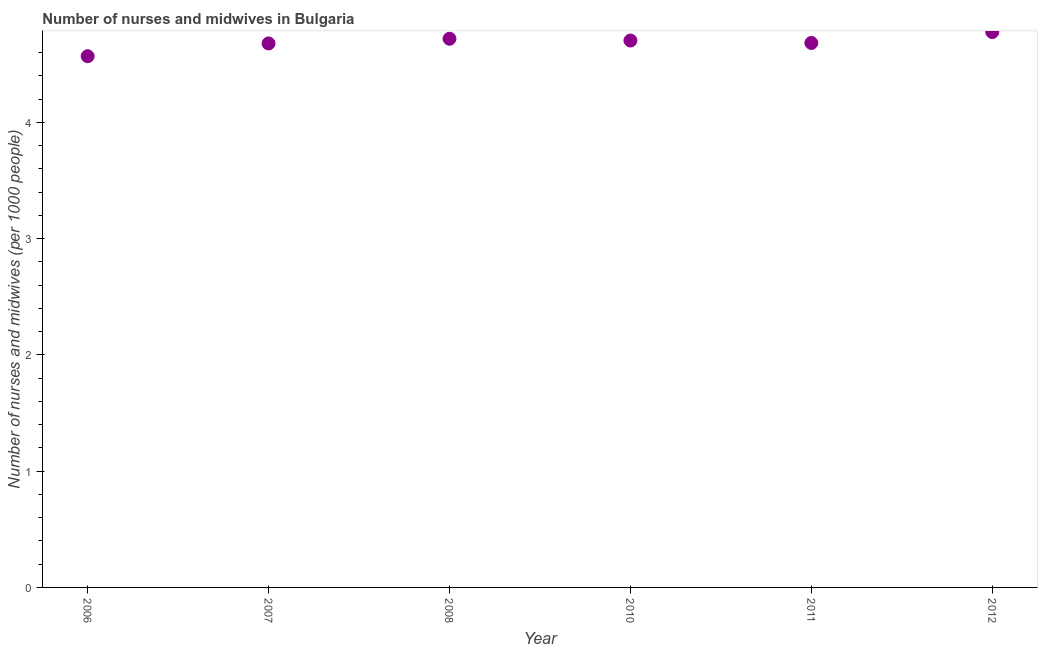What is the number of nurses and midwives in 2011?
Offer a terse response. 4.68. Across all years, what is the maximum number of nurses and midwives?
Offer a terse response. 4.78. Across all years, what is the minimum number of nurses and midwives?
Offer a terse response. 4.57. In which year was the number of nurses and midwives maximum?
Your response must be concise. 2012. In which year was the number of nurses and midwives minimum?
Offer a very short reply. 2006. What is the sum of the number of nurses and midwives?
Offer a very short reply. 28.14. What is the difference between the number of nurses and midwives in 2006 and 2011?
Your answer should be compact. -0.11. What is the average number of nurses and midwives per year?
Your answer should be very brief. 4.69. What is the median number of nurses and midwives?
Give a very brief answer. 4.69. In how many years, is the number of nurses and midwives greater than 2 ?
Offer a very short reply. 6. Do a majority of the years between 2012 and 2011 (inclusive) have number of nurses and midwives greater than 1.4 ?
Keep it short and to the point. No. What is the ratio of the number of nurses and midwives in 2006 to that in 2011?
Ensure brevity in your answer.  0.98. Is the difference between the number of nurses and midwives in 2007 and 2008 greater than the difference between any two years?
Your answer should be compact. No. What is the difference between the highest and the second highest number of nurses and midwives?
Offer a terse response. 0.06. Is the sum of the number of nurses and midwives in 2006 and 2007 greater than the maximum number of nurses and midwives across all years?
Ensure brevity in your answer.  Yes. What is the difference between the highest and the lowest number of nurses and midwives?
Offer a very short reply. 0.21. Does the number of nurses and midwives monotonically increase over the years?
Your response must be concise. No. What is the difference between two consecutive major ticks on the Y-axis?
Provide a short and direct response. 1. Does the graph contain grids?
Provide a short and direct response. No. What is the title of the graph?
Your answer should be compact. Number of nurses and midwives in Bulgaria. What is the label or title of the X-axis?
Your answer should be compact. Year. What is the label or title of the Y-axis?
Offer a very short reply. Number of nurses and midwives (per 1000 people). What is the Number of nurses and midwives (per 1000 people) in 2006?
Your answer should be very brief. 4.57. What is the Number of nurses and midwives (per 1000 people) in 2007?
Provide a short and direct response. 4.68. What is the Number of nurses and midwives (per 1000 people) in 2008?
Your answer should be very brief. 4.72. What is the Number of nurses and midwives (per 1000 people) in 2010?
Provide a short and direct response. 4.71. What is the Number of nurses and midwives (per 1000 people) in 2011?
Your answer should be very brief. 4.68. What is the Number of nurses and midwives (per 1000 people) in 2012?
Ensure brevity in your answer.  4.78. What is the difference between the Number of nurses and midwives (per 1000 people) in 2006 and 2007?
Provide a short and direct response. -0.11. What is the difference between the Number of nurses and midwives (per 1000 people) in 2006 and 2008?
Your response must be concise. -0.15. What is the difference between the Number of nurses and midwives (per 1000 people) in 2006 and 2010?
Provide a short and direct response. -0.14. What is the difference between the Number of nurses and midwives (per 1000 people) in 2006 and 2011?
Provide a short and direct response. -0.11. What is the difference between the Number of nurses and midwives (per 1000 people) in 2006 and 2012?
Your answer should be compact. -0.21. What is the difference between the Number of nurses and midwives (per 1000 people) in 2007 and 2008?
Provide a succinct answer. -0.04. What is the difference between the Number of nurses and midwives (per 1000 people) in 2007 and 2010?
Make the answer very short. -0.03. What is the difference between the Number of nurses and midwives (per 1000 people) in 2007 and 2011?
Make the answer very short. -0. What is the difference between the Number of nurses and midwives (per 1000 people) in 2007 and 2012?
Make the answer very short. -0.1. What is the difference between the Number of nurses and midwives (per 1000 people) in 2008 and 2010?
Offer a very short reply. 0.01. What is the difference between the Number of nurses and midwives (per 1000 people) in 2008 and 2011?
Provide a succinct answer. 0.04. What is the difference between the Number of nurses and midwives (per 1000 people) in 2008 and 2012?
Offer a very short reply. -0.06. What is the difference between the Number of nurses and midwives (per 1000 people) in 2010 and 2011?
Give a very brief answer. 0.02. What is the difference between the Number of nurses and midwives (per 1000 people) in 2010 and 2012?
Offer a terse response. -0.07. What is the difference between the Number of nurses and midwives (per 1000 people) in 2011 and 2012?
Keep it short and to the point. -0.09. What is the ratio of the Number of nurses and midwives (per 1000 people) in 2006 to that in 2007?
Provide a short and direct response. 0.98. What is the ratio of the Number of nurses and midwives (per 1000 people) in 2006 to that in 2010?
Offer a very short reply. 0.97. What is the ratio of the Number of nurses and midwives (per 1000 people) in 2006 to that in 2011?
Make the answer very short. 0.98. What is the ratio of the Number of nurses and midwives (per 1000 people) in 2006 to that in 2012?
Provide a succinct answer. 0.96. What is the ratio of the Number of nurses and midwives (per 1000 people) in 2007 to that in 2008?
Provide a short and direct response. 0.99. What is the ratio of the Number of nurses and midwives (per 1000 people) in 2007 to that in 2010?
Ensure brevity in your answer.  0.99. What is the ratio of the Number of nurses and midwives (per 1000 people) in 2007 to that in 2011?
Your response must be concise. 1. What is the ratio of the Number of nurses and midwives (per 1000 people) in 2008 to that in 2011?
Keep it short and to the point. 1.01. 